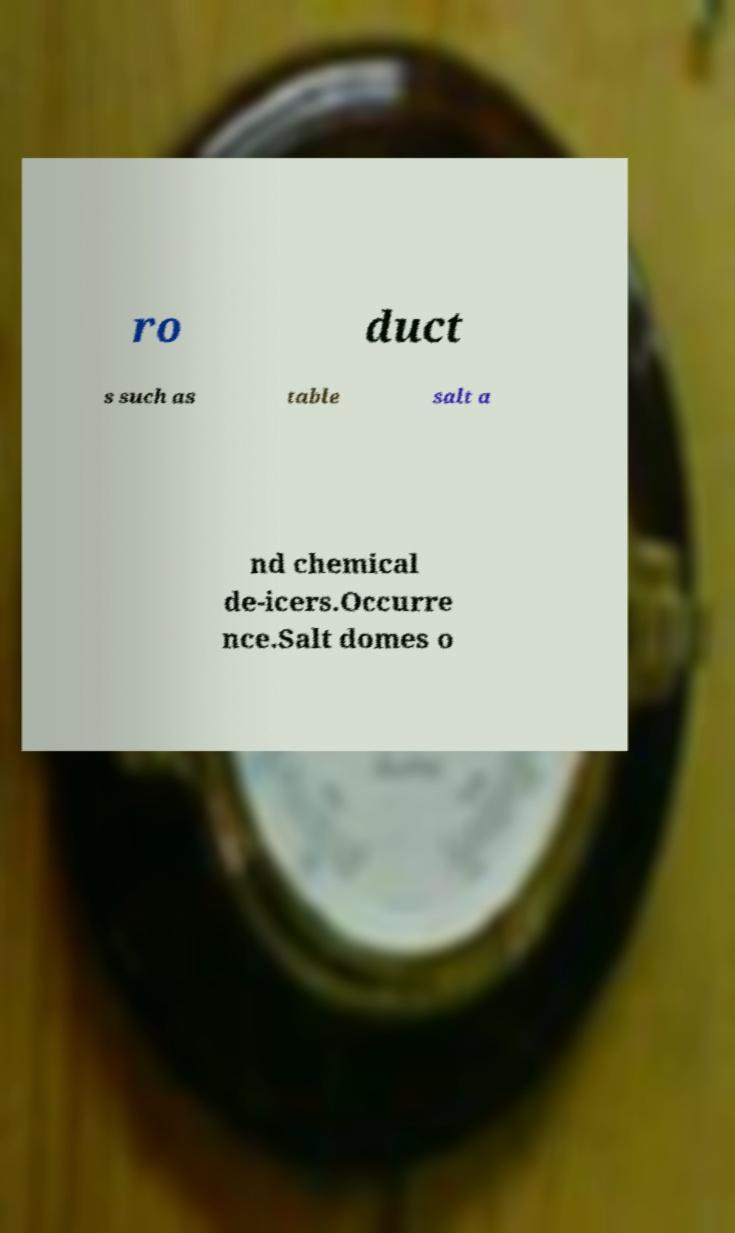Please read and relay the text visible in this image. What does it say? ro duct s such as table salt a nd chemical de-icers.Occurre nce.Salt domes o 